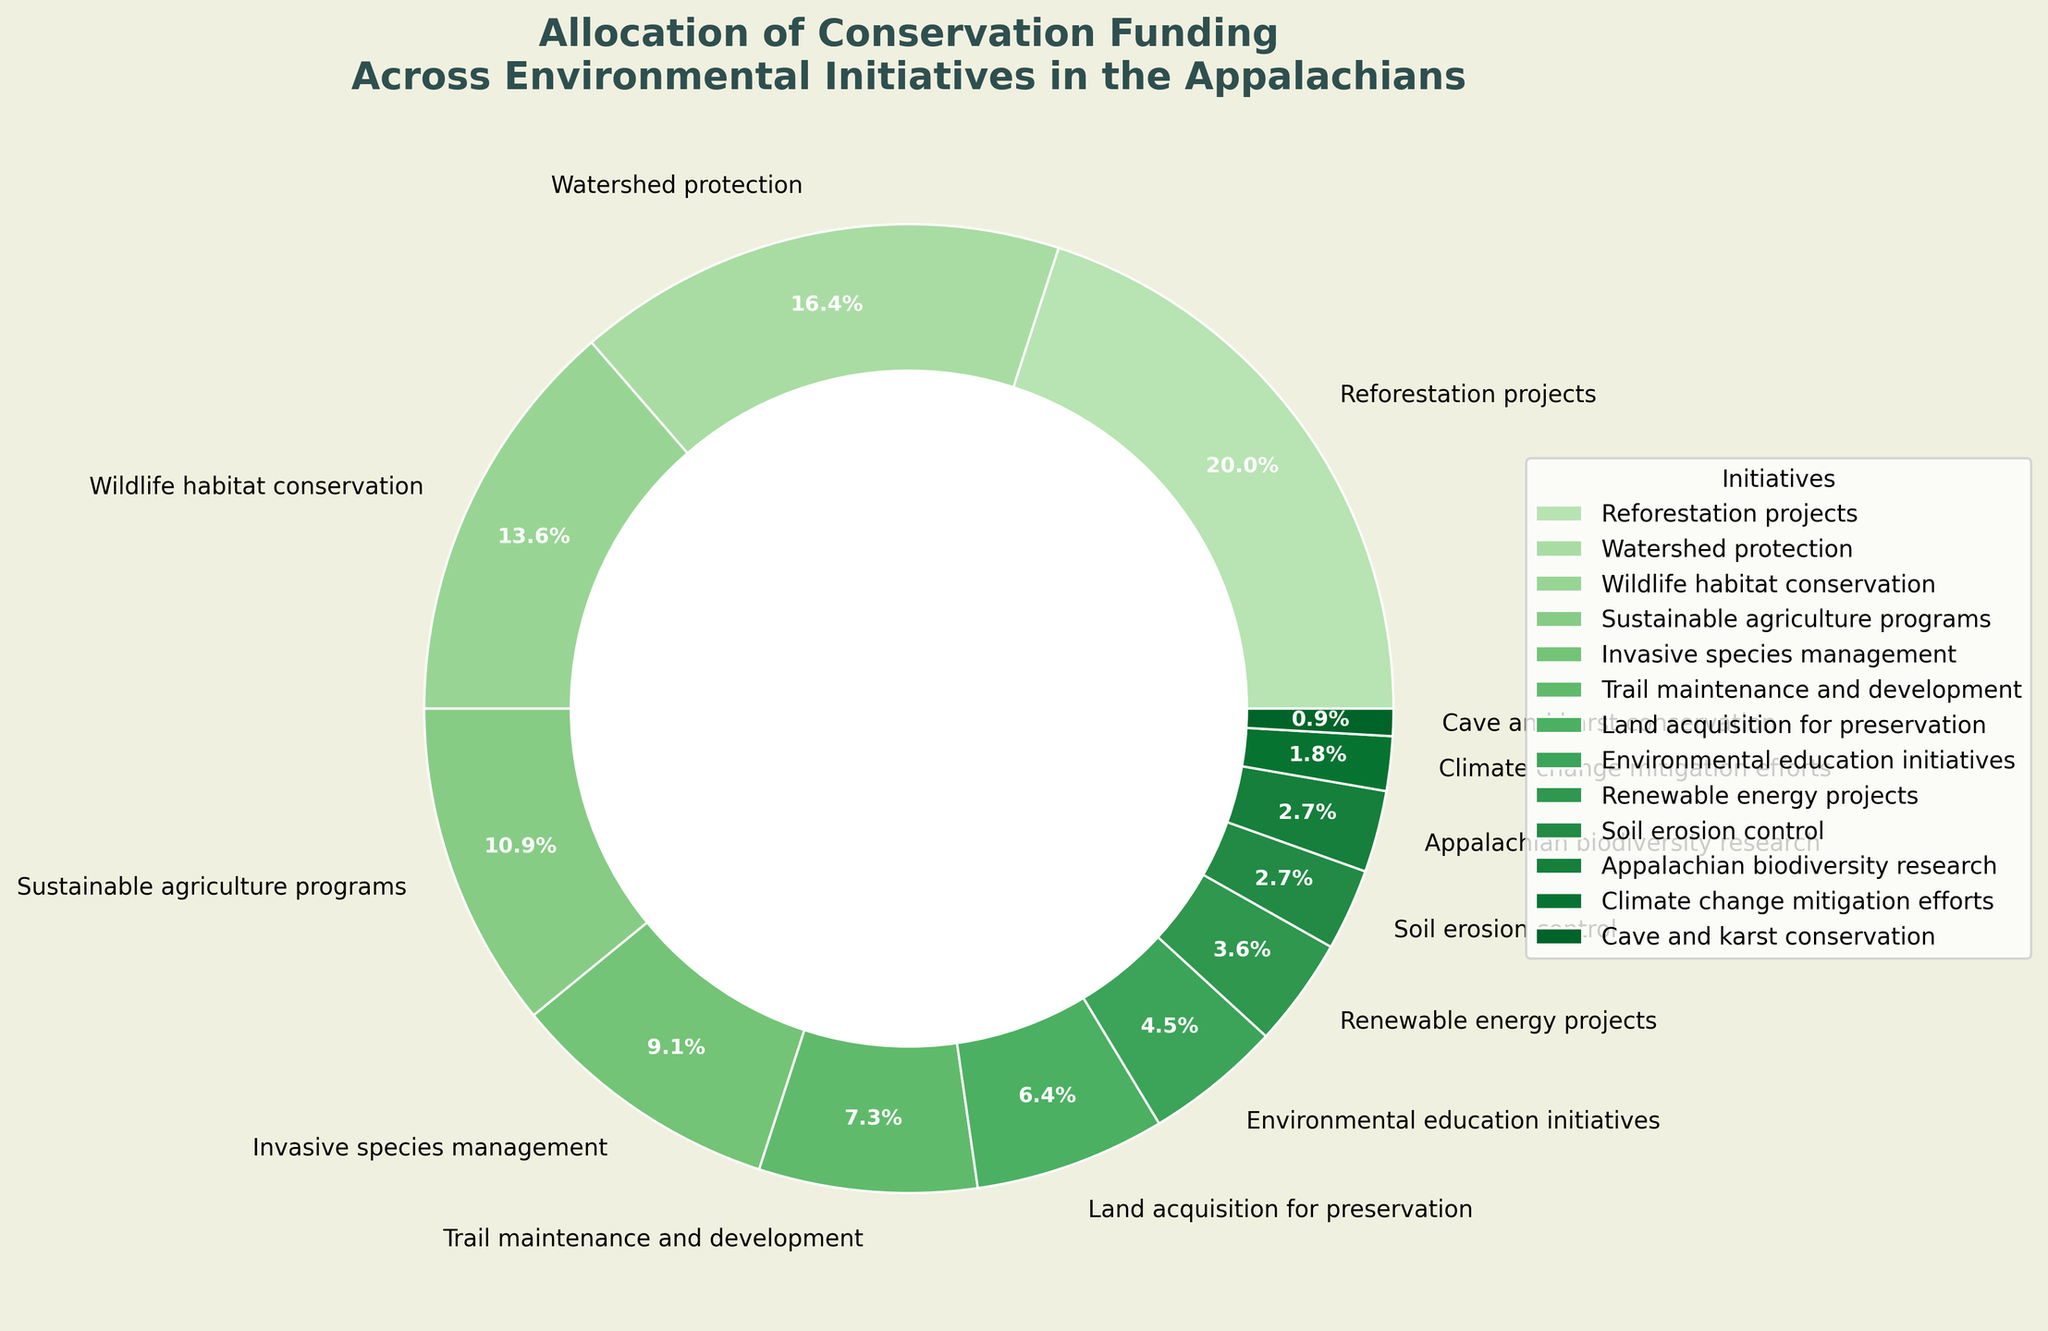What is the largest funding allocation? The largest slice of the pie chart represents reforestation projects, with a 22% allocation, as it has the biggest wedge and corresponding percentage label.
Answer: Reforestation projects (22%) How much more funding does reforestation receive compared to climate change mitigation efforts? The reforestation projects receive 22%, while climate change mitigation efforts receive 2%. The difference is calculated by subtracting 2% from 22%.
Answer: 20% Between invasive species management and soil erosion control, which initiative receives more funding? Invasive species management has a larger wedge, showing a 10% allocation, while soil erosion control has a smaller wedge, showing a 3% allocation.
Answer: Invasive species management (10%) What percentage of the total funding is allocated to initiatives with less than 10% each? Summing the percentages of initiatives with less than 10%: Trail maintenance (8%), Land acquisition (7%), Environmental education (5%), Renewable energy (4%), Soil erosion control (3%), Appalachian biodiversity (3%), Climate change mitigation (2%), and Cave and karst conservation (1%).
Answer: 33% What initiatives together make up exactly 30% of the funding? Combining sustainable agriculture programs (12%), invasive species management (10%), and trail maintenance and development (8%) results in a sum of 30% (12 + 10 + 8).
Answer: Sustainable agriculture programs, invasive species management, and trail maintenance and development How much more funding allocation does wildlife habitat conservation get compared to sustainable agriculture programs? Wildlife habitat conservation receives 15%, while sustainable agriculture programs get 12%. The difference is calculated by subtracting 12% from 15%.
Answer: 3% What is the combined funding percentage for cave and karst conservation and Appalachian biodiversity research? Adding the funding percentages for cave and karst conservation (1%) and Appalachian biodiversity research (3%) gives the total.
Answer: 4% Is the funding for watershed protection greater than the funding for land acquisition? Watershed protection has an allocation of 18%, while land acquisition for preservation is allocated 7%. Visually, watershed protection has a larger wedge.
Answer: Yes Among wildlife habitat conservation, invasive species management, and soil erosion control, which initiative receives the least funding? Soil erosion control receives 3%, which is less compared to wildlife habitat conservation (15%) and invasive species management (10%). Visually, soil erosion control has the smallest wedge among the three.
Answer: Soil erosion control (3%) What is the percentage difference between renewable energy projects and environmental education initiatives funding? Renewable energy projects receive 4% of the funding, and environmental education initiatives receive 5%. The percentage difference is calculated by subtracting 4% from 5%.
Answer: 1% 